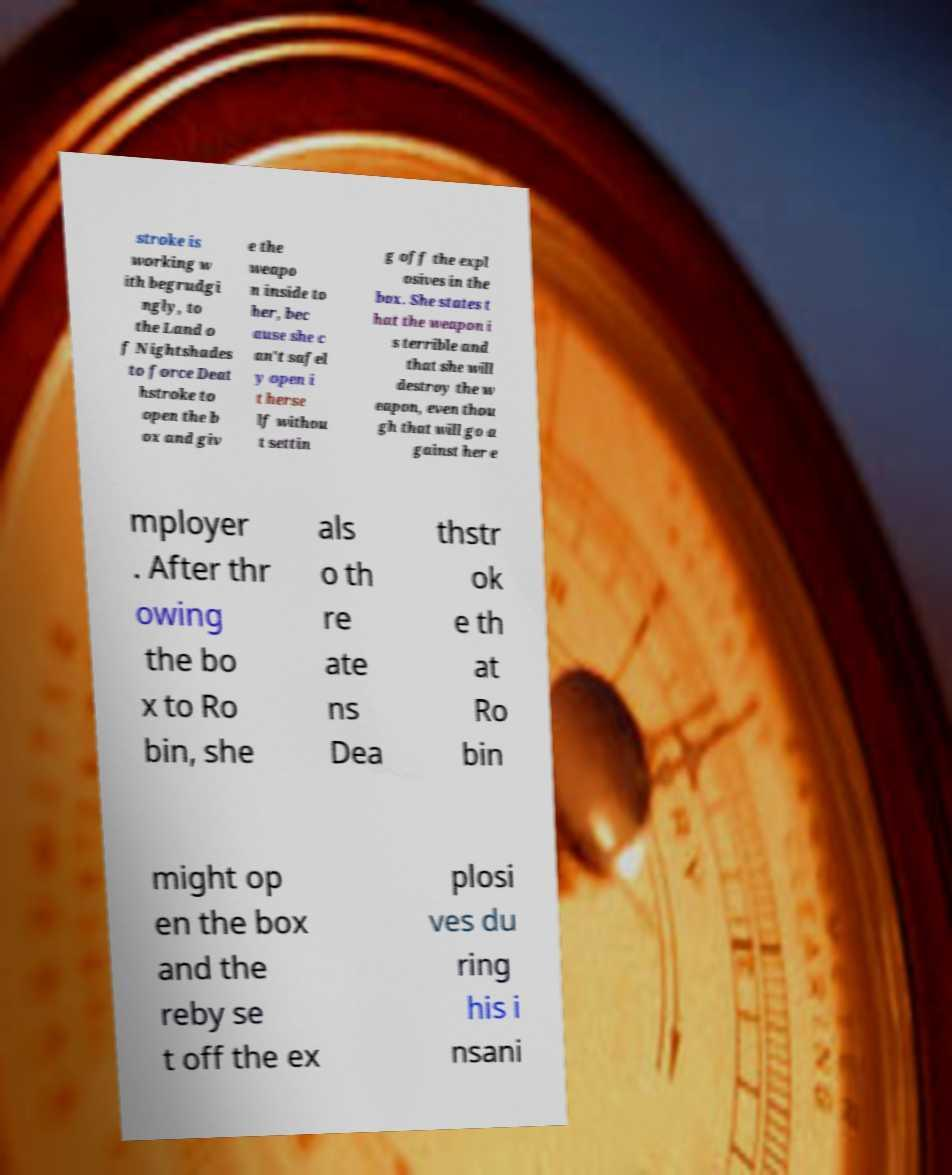I need the written content from this picture converted into text. Can you do that? stroke is working w ith begrudgi ngly, to the Land o f Nightshades to force Deat hstroke to open the b ox and giv e the weapo n inside to her, bec ause she c an't safel y open i t herse lf withou t settin g off the expl osives in the box. She states t hat the weapon i s terrible and that she will destroy the w eapon, even thou gh that will go a gainst her e mployer . After thr owing the bo x to Ro bin, she als o th re ate ns Dea thstr ok e th at Ro bin might op en the box and the reby se t off the ex plosi ves du ring his i nsani 